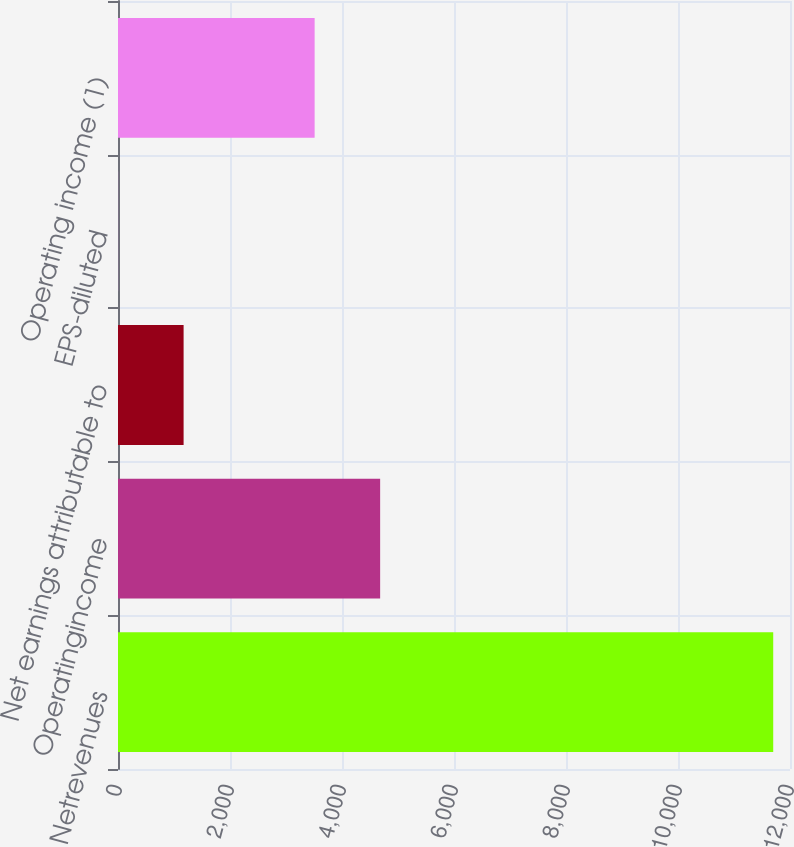Convert chart to OTSL. <chart><loc_0><loc_0><loc_500><loc_500><bar_chart><fcel>Netrevenues<fcel>Operatingincome<fcel>Net earnings attributable to<fcel>EPS-diluted<fcel>Operating income (1)<nl><fcel>11700.4<fcel>4681.14<fcel>1171.5<fcel>1.62<fcel>3511.26<nl></chart> 